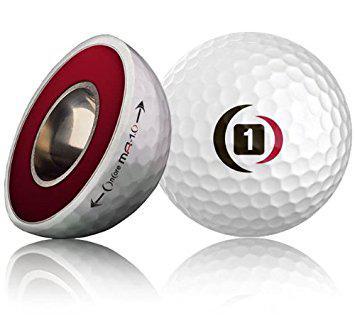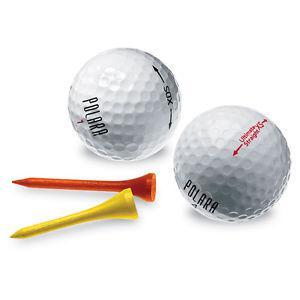The first image is the image on the left, the second image is the image on the right. Examine the images to the left and right. Is the description "At least one image contains a single whole golf ball." accurate? Answer yes or no. Yes. 